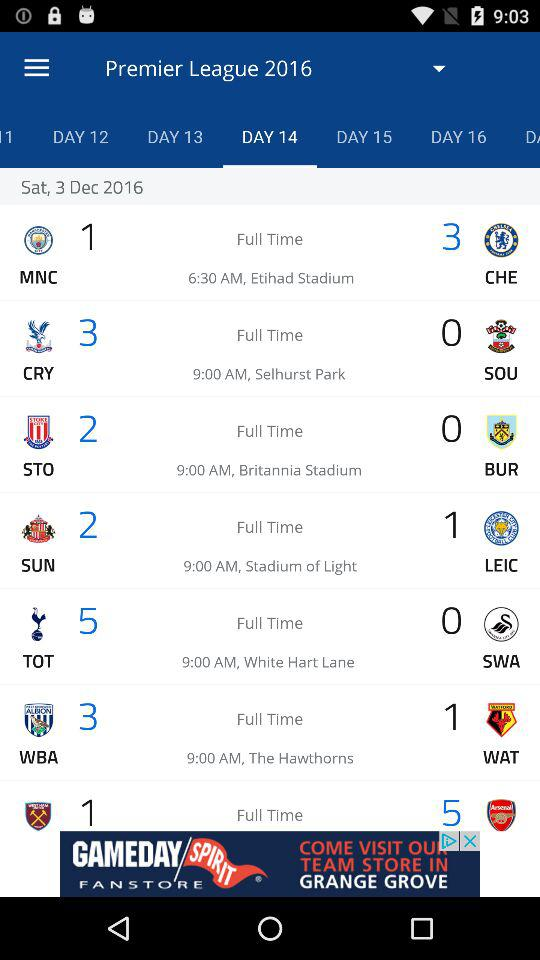What is the name of the tournament? The name of the tournament is "Premier League 2016". 